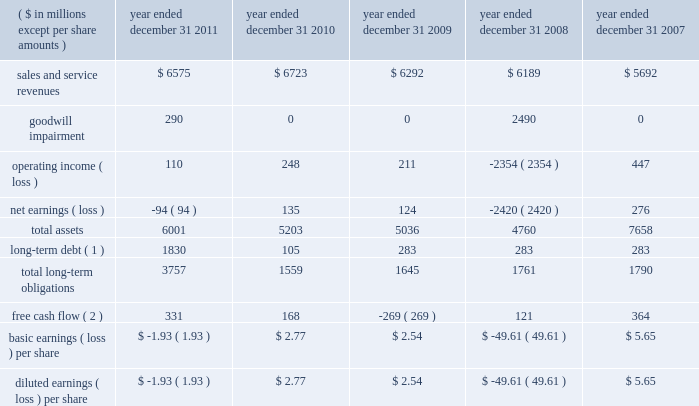( 1 ) the cumulative total return assumes reinvestment of dividends .
( 2 ) the total return is weighted according to market capitalization of each company at the beginning of each year .
( f ) purchases of equity securities by the issuer and affiliated purchasers we have not repurchased any of our common stock since the company filed its initial registration statement on march 16 , ( g ) securities authorized for issuance under equity compensation plans a description of securities authorized for issuance under our equity compensation plans will be incorporated herein by reference to the proxy statement for the 2012 annual meeting of stockholders to be filed within 120 days after the end of the company 2019s fiscal year .
Item 6 .
Selected financial data .
( 1 ) long-term debt does not include amounts payable to our former parent as of and before december 31 , 2010 , as these amounts were due upon demand and included in current liabilities .
( 2 ) free cash flow is a non-gaap financial measure and represents cash from operating activities less capital expenditures .
See liquidity and capital resources in item 7 for more information on this measure. .
What would 2011 operating income have been without non-cash charges? 
Computations: ((110 + 290) * 1000000)
Answer: 400000000.0. 